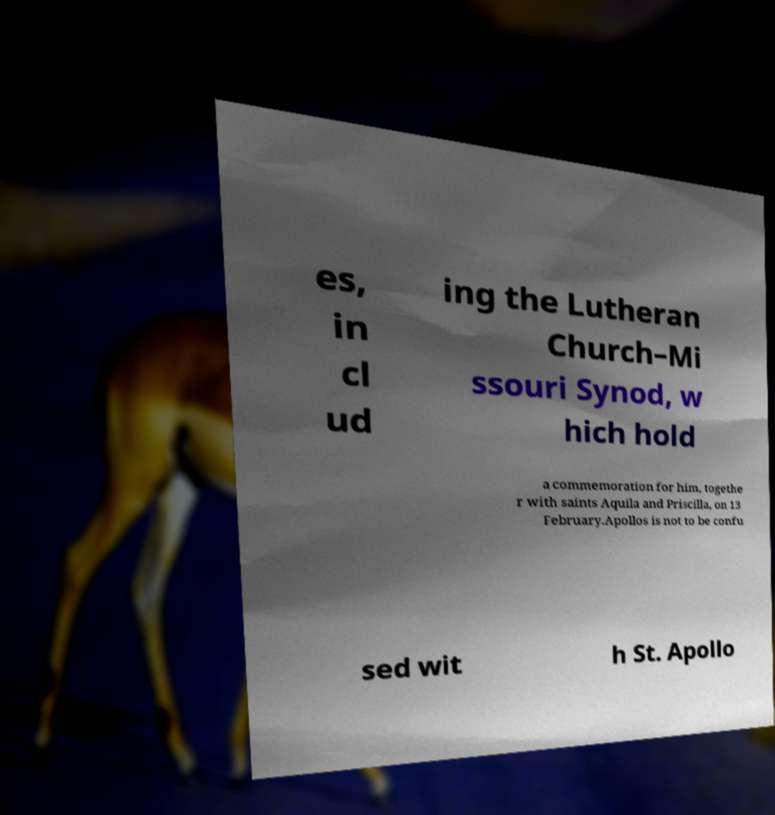Could you extract and type out the text from this image? es, in cl ud ing the Lutheran Church–Mi ssouri Synod, w hich hold a commemoration for him, togethe r with saints Aquila and Priscilla, on 13 February.Apollos is not to be confu sed wit h St. Apollo 